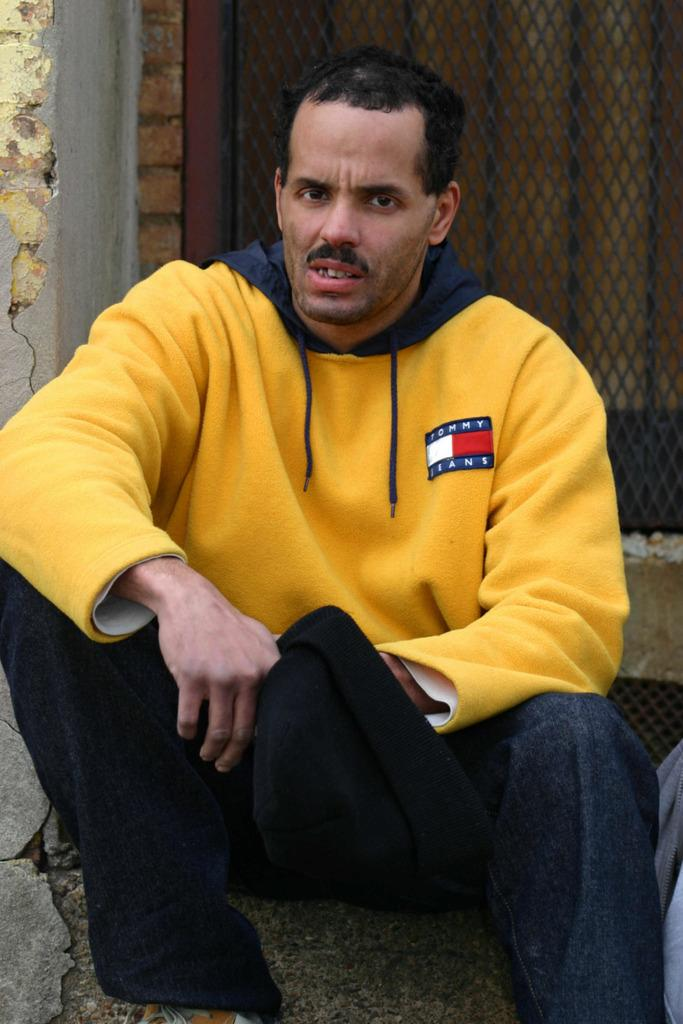<image>
Provide a brief description of the given image. A man sits on the ground in a yellow Tommy Jeans sweatshirt on. 